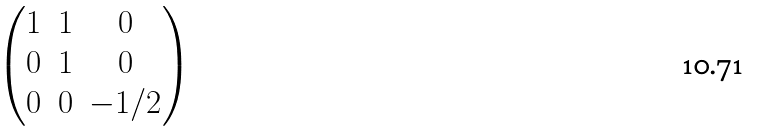Convert formula to latex. <formula><loc_0><loc_0><loc_500><loc_500>\begin{pmatrix} 1 & 1 & 0 \\ 0 & 1 & 0 \\ 0 & 0 & - 1 / 2 \end{pmatrix}</formula> 